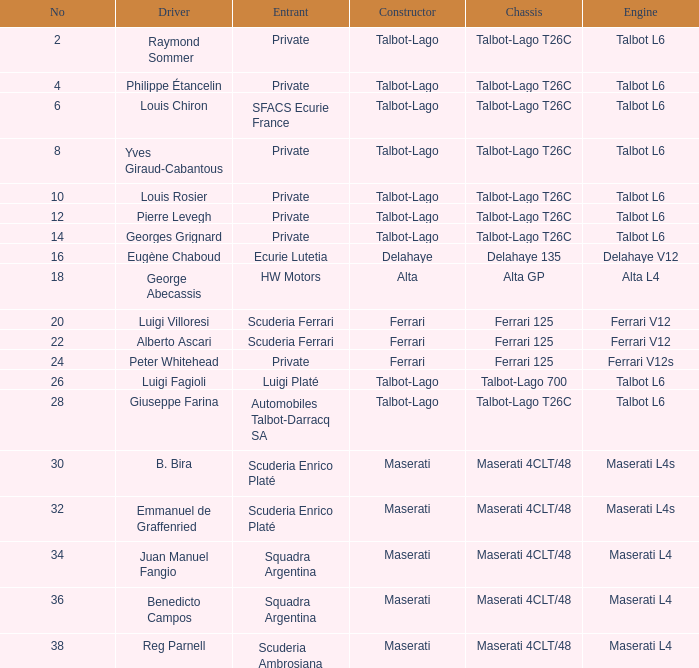What is the chassis used by b. bira? Maserati 4CLT/48. 